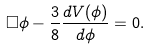Convert formula to latex. <formula><loc_0><loc_0><loc_500><loc_500>\Box \phi - \frac { 3 } { 8 } \frac { d V ( \phi ) } { d \phi } = 0 .</formula> 